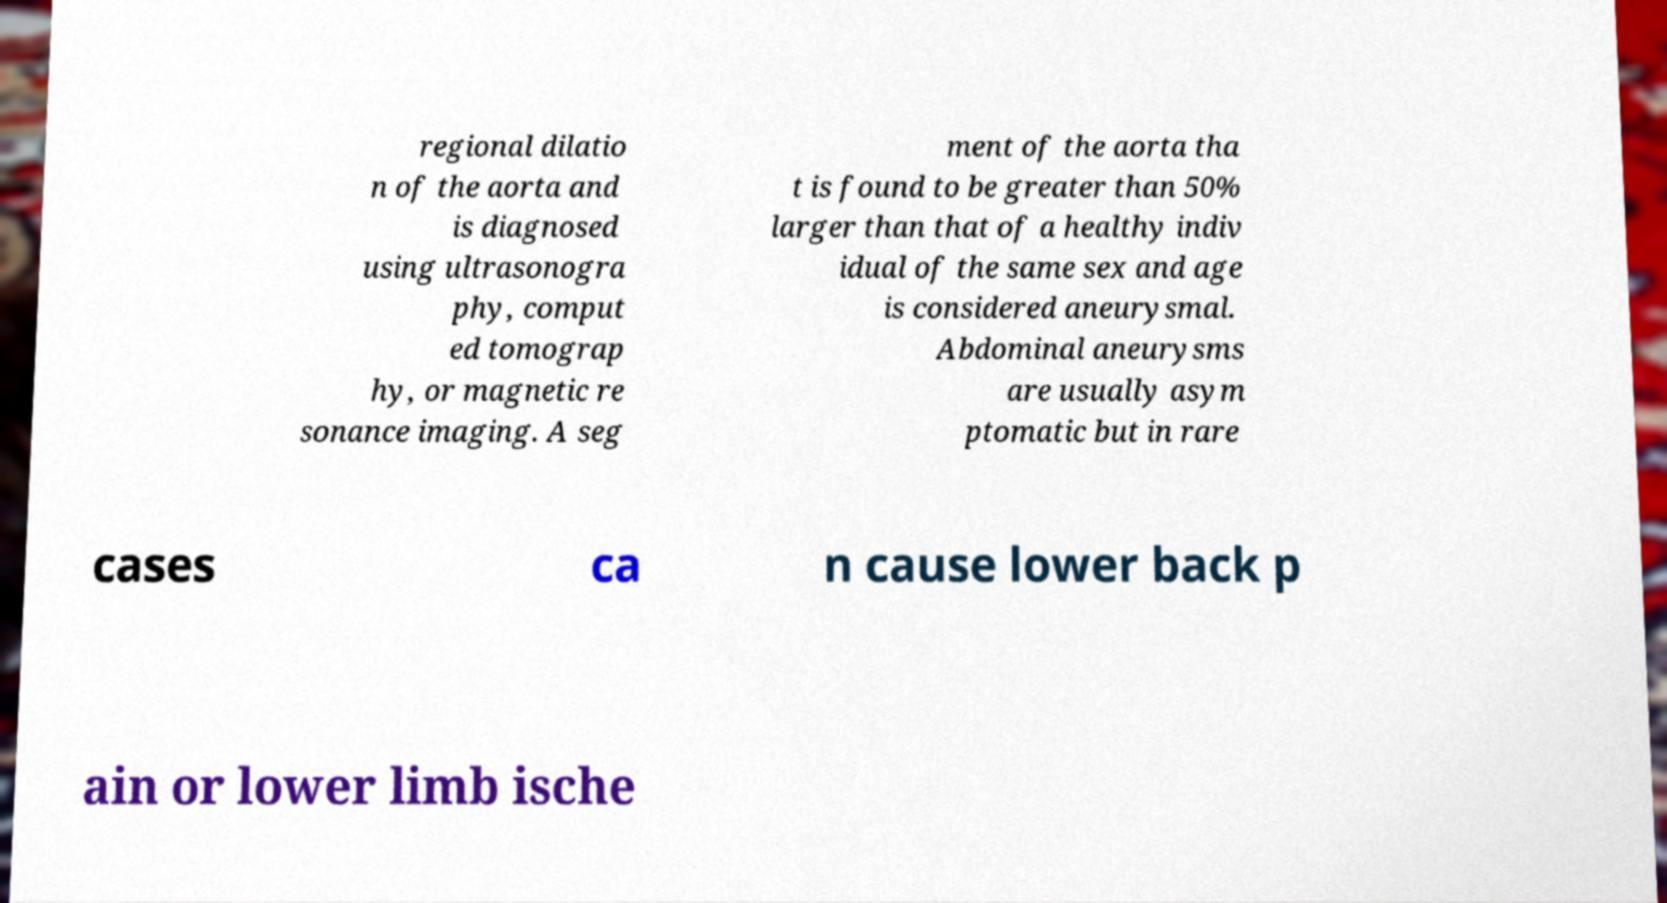Please read and relay the text visible in this image. What does it say? regional dilatio n of the aorta and is diagnosed using ultrasonogra phy, comput ed tomograp hy, or magnetic re sonance imaging. A seg ment of the aorta tha t is found to be greater than 50% larger than that of a healthy indiv idual of the same sex and age is considered aneurysmal. Abdominal aneurysms are usually asym ptomatic but in rare cases ca n cause lower back p ain or lower limb ische 